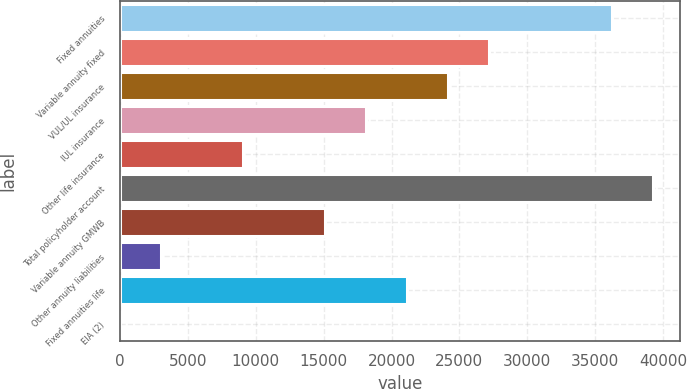Convert chart. <chart><loc_0><loc_0><loc_500><loc_500><bar_chart><fcel>Fixed annuities<fcel>Variable annuity fixed<fcel>VUL/UL insurance<fcel>IUL insurance<fcel>Other life insurance<fcel>Total policyholder account<fcel>Variable annuity GMWB<fcel>Other annuity liabilities<fcel>Fixed annuities life<fcel>EIA (2)<nl><fcel>36237.4<fcel>27184.3<fcel>24166.6<fcel>18131.2<fcel>9078.1<fcel>39255.1<fcel>15113.5<fcel>3042.7<fcel>21148.9<fcel>25<nl></chart> 